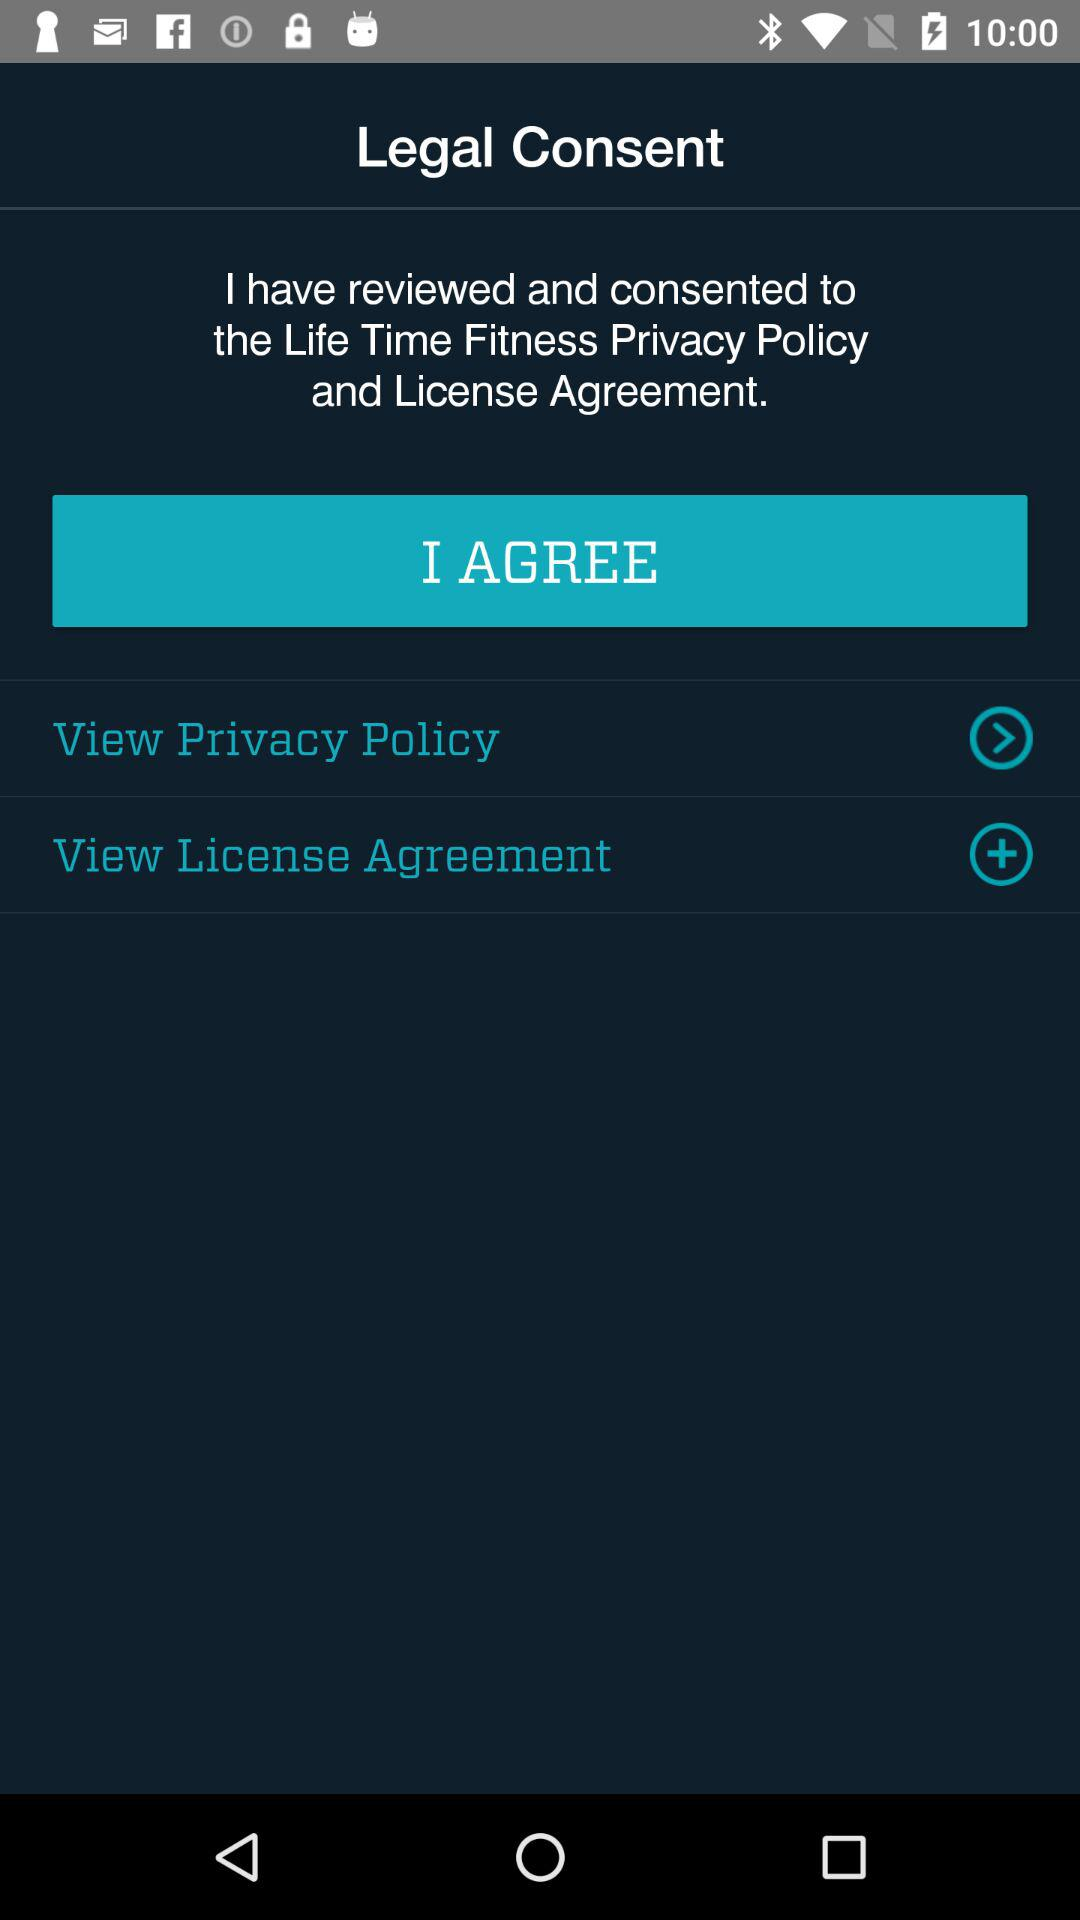What is the name of the application? The name of the application is "Legal Consent". 